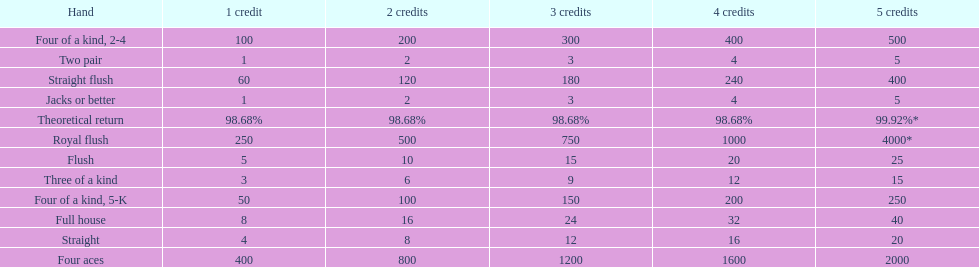Give me the full table as a dictionary. {'header': ['Hand', '1 credit', '2 credits', '3 credits', '4 credits', '5 credits'], 'rows': [['Four of a kind, 2-4', '100', '200', '300', '400', '500'], ['Two pair', '1', '2', '3', '4', '5'], ['Straight flush', '60', '120', '180', '240', '400'], ['Jacks or better', '1', '2', '3', '4', '5'], ['Theoretical return', '98.68%', '98.68%', '98.68%', '98.68%', '99.92%*'], ['Royal flush', '250', '500', '750', '1000', '4000*'], ['Flush', '5', '10', '15', '20', '25'], ['Three of a kind', '3', '6', '9', '12', '15'], ['Four of a kind, 5-K', '50', '100', '150', '200', '250'], ['Full house', '8', '16', '24', '32', '40'], ['Straight', '4', '8', '12', '16', '20'], ['Four aces', '400', '800', '1200', '1600', '2000']]} Each four aces win is a multiple of what number? 400. 